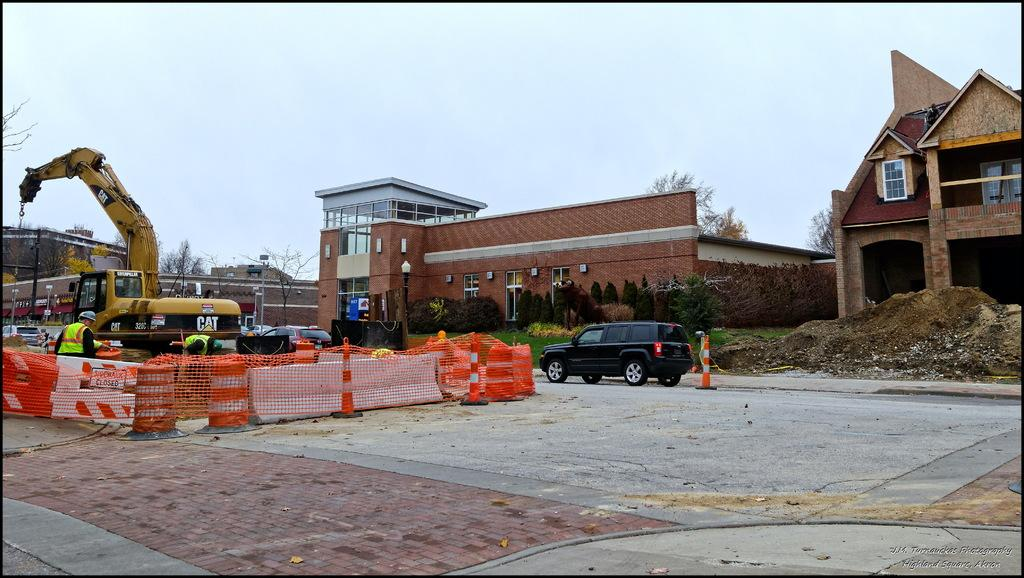What type of structures can be seen in the image? There are buildings in the image. What natural elements are present in the image? There are trees and grass in the image. What mode of transportation is visible in the image? There is a car in the image. What construction equipment is present in the image? There is a crane in the image. What part of the natural environment is visible in the image? The sky is visible at the top of the image. What type of reward is being given to the key in the image? There is no reward or key present in the image. How much sugar is visible in the image? There is no sugar visible in the image. 